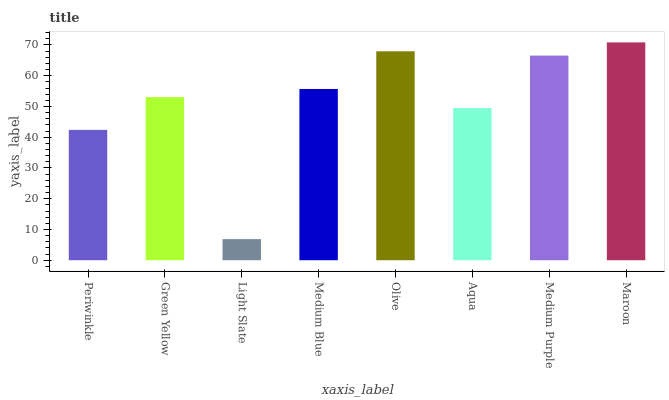Is Green Yellow the minimum?
Answer yes or no. No. Is Green Yellow the maximum?
Answer yes or no. No. Is Green Yellow greater than Periwinkle?
Answer yes or no. Yes. Is Periwinkle less than Green Yellow?
Answer yes or no. Yes. Is Periwinkle greater than Green Yellow?
Answer yes or no. No. Is Green Yellow less than Periwinkle?
Answer yes or no. No. Is Medium Blue the high median?
Answer yes or no. Yes. Is Green Yellow the low median?
Answer yes or no. Yes. Is Periwinkle the high median?
Answer yes or no. No. Is Medium Purple the low median?
Answer yes or no. No. 